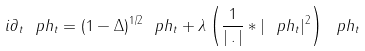Convert formula to latex. <formula><loc_0><loc_0><loc_500><loc_500>i \partial _ { t } \ p h _ { t } = ( 1 - \Delta ) ^ { 1 / 2 } \ p h _ { t } + \lambda \left ( \frac { 1 } { | \, . \, | } * | \ p h _ { t } | ^ { 2 } \right ) \ p h _ { t }</formula> 